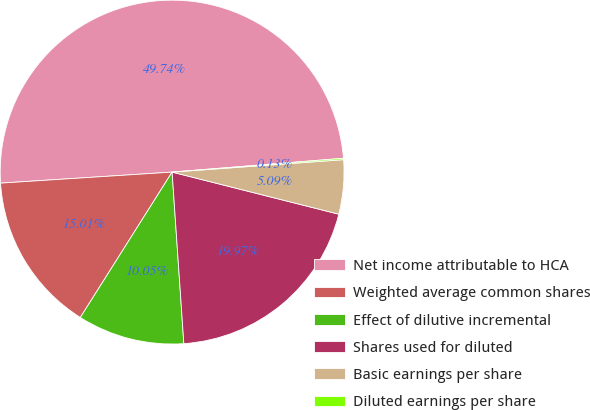Convert chart. <chart><loc_0><loc_0><loc_500><loc_500><pie_chart><fcel>Net income attributable to HCA<fcel>Weighted average common shares<fcel>Effect of dilutive incremental<fcel>Shares used for diluted<fcel>Basic earnings per share<fcel>Diluted earnings per share<nl><fcel>49.73%<fcel>15.01%<fcel>10.05%<fcel>19.97%<fcel>5.09%<fcel>0.13%<nl></chart> 